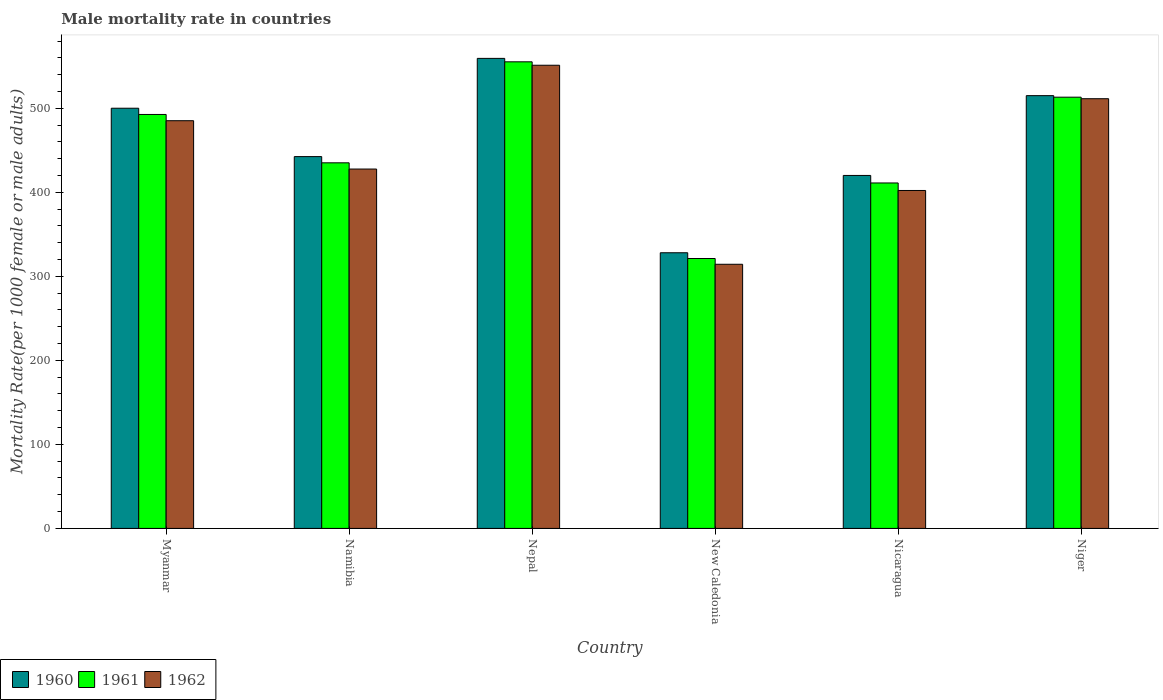How many different coloured bars are there?
Give a very brief answer. 3. Are the number of bars per tick equal to the number of legend labels?
Keep it short and to the point. Yes. How many bars are there on the 4th tick from the right?
Your answer should be very brief. 3. What is the label of the 2nd group of bars from the left?
Give a very brief answer. Namibia. In how many cases, is the number of bars for a given country not equal to the number of legend labels?
Your response must be concise. 0. What is the male mortality rate in 1962 in Nicaragua?
Your answer should be compact. 402.13. Across all countries, what is the maximum male mortality rate in 1962?
Make the answer very short. 551.15. Across all countries, what is the minimum male mortality rate in 1962?
Your answer should be very brief. 314.32. In which country was the male mortality rate in 1961 maximum?
Provide a succinct answer. Nepal. In which country was the male mortality rate in 1962 minimum?
Your response must be concise. New Caledonia. What is the total male mortality rate in 1960 in the graph?
Provide a succinct answer. 2764.8. What is the difference between the male mortality rate in 1961 in Namibia and that in Niger?
Give a very brief answer. -78.11. What is the difference between the male mortality rate in 1962 in Nepal and the male mortality rate in 1961 in New Caledonia?
Your answer should be very brief. 229.98. What is the average male mortality rate in 1960 per country?
Give a very brief answer. 460.8. What is the difference between the male mortality rate of/in 1960 and male mortality rate of/in 1962 in Niger?
Your answer should be compact. 3.64. In how many countries, is the male mortality rate in 1962 greater than 60?
Keep it short and to the point. 6. What is the ratio of the male mortality rate in 1961 in Myanmar to that in Niger?
Keep it short and to the point. 0.96. Is the male mortality rate in 1961 in Nicaragua less than that in Niger?
Give a very brief answer. Yes. What is the difference between the highest and the second highest male mortality rate in 1960?
Your answer should be very brief. 14.97. What is the difference between the highest and the lowest male mortality rate in 1961?
Your answer should be very brief. 234.07. What is the difference between two consecutive major ticks on the Y-axis?
Your answer should be compact. 100. Are the values on the major ticks of Y-axis written in scientific E-notation?
Provide a short and direct response. No. Does the graph contain any zero values?
Offer a terse response. No. Does the graph contain grids?
Your answer should be compact. No. What is the title of the graph?
Ensure brevity in your answer.  Male mortality rate in countries. What is the label or title of the Y-axis?
Provide a succinct answer. Mortality Rate(per 1000 female or male adults). What is the Mortality Rate(per 1000 female or male adults) in 1960 in Myanmar?
Provide a short and direct response. 500. What is the Mortality Rate(per 1000 female or male adults) of 1961 in Myanmar?
Provide a succinct answer. 492.58. What is the Mortality Rate(per 1000 female or male adults) of 1962 in Myanmar?
Keep it short and to the point. 485.16. What is the Mortality Rate(per 1000 female or male adults) of 1960 in Namibia?
Your answer should be compact. 442.45. What is the Mortality Rate(per 1000 female or male adults) of 1961 in Namibia?
Your answer should be compact. 435.05. What is the Mortality Rate(per 1000 female or male adults) in 1962 in Namibia?
Your response must be concise. 427.65. What is the Mortality Rate(per 1000 female or male adults) in 1960 in Nepal?
Keep it short and to the point. 559.33. What is the Mortality Rate(per 1000 female or male adults) of 1961 in Nepal?
Your response must be concise. 555.24. What is the Mortality Rate(per 1000 female or male adults) of 1962 in Nepal?
Offer a terse response. 551.15. What is the Mortality Rate(per 1000 female or male adults) in 1960 in New Caledonia?
Ensure brevity in your answer.  328.03. What is the Mortality Rate(per 1000 female or male adults) in 1961 in New Caledonia?
Provide a succinct answer. 321.17. What is the Mortality Rate(per 1000 female or male adults) in 1962 in New Caledonia?
Your answer should be very brief. 314.32. What is the Mortality Rate(per 1000 female or male adults) of 1960 in Nicaragua?
Provide a succinct answer. 420.02. What is the Mortality Rate(per 1000 female or male adults) in 1961 in Nicaragua?
Make the answer very short. 411.07. What is the Mortality Rate(per 1000 female or male adults) in 1962 in Nicaragua?
Keep it short and to the point. 402.13. What is the Mortality Rate(per 1000 female or male adults) of 1960 in Niger?
Ensure brevity in your answer.  514.98. What is the Mortality Rate(per 1000 female or male adults) of 1961 in Niger?
Give a very brief answer. 513.16. What is the Mortality Rate(per 1000 female or male adults) in 1962 in Niger?
Your answer should be compact. 511.34. Across all countries, what is the maximum Mortality Rate(per 1000 female or male adults) of 1960?
Provide a succinct answer. 559.33. Across all countries, what is the maximum Mortality Rate(per 1000 female or male adults) of 1961?
Your answer should be compact. 555.24. Across all countries, what is the maximum Mortality Rate(per 1000 female or male adults) of 1962?
Keep it short and to the point. 551.15. Across all countries, what is the minimum Mortality Rate(per 1000 female or male adults) in 1960?
Make the answer very short. 328.03. Across all countries, what is the minimum Mortality Rate(per 1000 female or male adults) of 1961?
Your answer should be very brief. 321.17. Across all countries, what is the minimum Mortality Rate(per 1000 female or male adults) of 1962?
Your answer should be compact. 314.32. What is the total Mortality Rate(per 1000 female or male adults) in 1960 in the graph?
Your response must be concise. 2764.8. What is the total Mortality Rate(per 1000 female or male adults) of 1961 in the graph?
Your answer should be very brief. 2728.27. What is the total Mortality Rate(per 1000 female or male adults) in 1962 in the graph?
Your answer should be very brief. 2691.74. What is the difference between the Mortality Rate(per 1000 female or male adults) in 1960 in Myanmar and that in Namibia?
Your answer should be compact. 57.56. What is the difference between the Mortality Rate(per 1000 female or male adults) of 1961 in Myanmar and that in Namibia?
Make the answer very short. 57.53. What is the difference between the Mortality Rate(per 1000 female or male adults) in 1962 in Myanmar and that in Namibia?
Your answer should be very brief. 57.51. What is the difference between the Mortality Rate(per 1000 female or male adults) in 1960 in Myanmar and that in Nepal?
Offer a very short reply. -59.32. What is the difference between the Mortality Rate(per 1000 female or male adults) in 1961 in Myanmar and that in Nepal?
Give a very brief answer. -62.66. What is the difference between the Mortality Rate(per 1000 female or male adults) in 1962 in Myanmar and that in Nepal?
Your answer should be very brief. -65.99. What is the difference between the Mortality Rate(per 1000 female or male adults) of 1960 in Myanmar and that in New Caledonia?
Your answer should be compact. 171.98. What is the difference between the Mortality Rate(per 1000 female or male adults) in 1961 in Myanmar and that in New Caledonia?
Your answer should be very brief. 171.41. What is the difference between the Mortality Rate(per 1000 female or male adults) in 1962 in Myanmar and that in New Caledonia?
Keep it short and to the point. 170.84. What is the difference between the Mortality Rate(per 1000 female or male adults) in 1960 in Myanmar and that in Nicaragua?
Your answer should be very brief. 79.99. What is the difference between the Mortality Rate(per 1000 female or male adults) in 1961 in Myanmar and that in Nicaragua?
Your answer should be compact. 81.51. What is the difference between the Mortality Rate(per 1000 female or male adults) of 1962 in Myanmar and that in Nicaragua?
Offer a terse response. 83.03. What is the difference between the Mortality Rate(per 1000 female or male adults) of 1960 in Myanmar and that in Niger?
Give a very brief answer. -14.97. What is the difference between the Mortality Rate(per 1000 female or male adults) in 1961 in Myanmar and that in Niger?
Provide a succinct answer. -20.57. What is the difference between the Mortality Rate(per 1000 female or male adults) of 1962 in Myanmar and that in Niger?
Provide a short and direct response. -26.18. What is the difference between the Mortality Rate(per 1000 female or male adults) in 1960 in Namibia and that in Nepal?
Your answer should be compact. -116.88. What is the difference between the Mortality Rate(per 1000 female or male adults) of 1961 in Namibia and that in Nepal?
Your answer should be very brief. -120.19. What is the difference between the Mortality Rate(per 1000 female or male adults) of 1962 in Namibia and that in Nepal?
Your answer should be very brief. -123.5. What is the difference between the Mortality Rate(per 1000 female or male adults) in 1960 in Namibia and that in New Caledonia?
Provide a short and direct response. 114.42. What is the difference between the Mortality Rate(per 1000 female or male adults) of 1961 in Namibia and that in New Caledonia?
Offer a terse response. 113.87. What is the difference between the Mortality Rate(per 1000 female or male adults) in 1962 in Namibia and that in New Caledonia?
Your answer should be compact. 113.33. What is the difference between the Mortality Rate(per 1000 female or male adults) of 1960 in Namibia and that in Nicaragua?
Keep it short and to the point. 22.43. What is the difference between the Mortality Rate(per 1000 female or male adults) in 1961 in Namibia and that in Nicaragua?
Keep it short and to the point. 23.98. What is the difference between the Mortality Rate(per 1000 female or male adults) in 1962 in Namibia and that in Nicaragua?
Provide a short and direct response. 25.52. What is the difference between the Mortality Rate(per 1000 female or male adults) in 1960 in Namibia and that in Niger?
Offer a terse response. -72.53. What is the difference between the Mortality Rate(per 1000 female or male adults) in 1961 in Namibia and that in Niger?
Your answer should be compact. -78.11. What is the difference between the Mortality Rate(per 1000 female or male adults) in 1962 in Namibia and that in Niger?
Offer a very short reply. -83.69. What is the difference between the Mortality Rate(per 1000 female or male adults) of 1960 in Nepal and that in New Caledonia?
Provide a succinct answer. 231.3. What is the difference between the Mortality Rate(per 1000 female or male adults) of 1961 in Nepal and that in New Caledonia?
Provide a short and direct response. 234.07. What is the difference between the Mortality Rate(per 1000 female or male adults) of 1962 in Nepal and that in New Caledonia?
Give a very brief answer. 236.83. What is the difference between the Mortality Rate(per 1000 female or male adults) in 1960 in Nepal and that in Nicaragua?
Your answer should be very brief. 139.31. What is the difference between the Mortality Rate(per 1000 female or male adults) of 1961 in Nepal and that in Nicaragua?
Provide a succinct answer. 144.17. What is the difference between the Mortality Rate(per 1000 female or male adults) in 1962 in Nepal and that in Nicaragua?
Offer a terse response. 149.02. What is the difference between the Mortality Rate(per 1000 female or male adults) in 1960 in Nepal and that in Niger?
Your answer should be very brief. 44.35. What is the difference between the Mortality Rate(per 1000 female or male adults) in 1961 in Nepal and that in Niger?
Your answer should be compact. 42.08. What is the difference between the Mortality Rate(per 1000 female or male adults) of 1962 in Nepal and that in Niger?
Your response must be concise. 39.81. What is the difference between the Mortality Rate(per 1000 female or male adults) in 1960 in New Caledonia and that in Nicaragua?
Your response must be concise. -91.99. What is the difference between the Mortality Rate(per 1000 female or male adults) in 1961 in New Caledonia and that in Nicaragua?
Your response must be concise. -89.9. What is the difference between the Mortality Rate(per 1000 female or male adults) of 1962 in New Caledonia and that in Nicaragua?
Your answer should be compact. -87.81. What is the difference between the Mortality Rate(per 1000 female or male adults) of 1960 in New Caledonia and that in Niger?
Offer a terse response. -186.95. What is the difference between the Mortality Rate(per 1000 female or male adults) in 1961 in New Caledonia and that in Niger?
Your answer should be compact. -191.98. What is the difference between the Mortality Rate(per 1000 female or male adults) in 1962 in New Caledonia and that in Niger?
Your response must be concise. -197.02. What is the difference between the Mortality Rate(per 1000 female or male adults) of 1960 in Nicaragua and that in Niger?
Offer a very short reply. -94.96. What is the difference between the Mortality Rate(per 1000 female or male adults) in 1961 in Nicaragua and that in Niger?
Your response must be concise. -102.08. What is the difference between the Mortality Rate(per 1000 female or male adults) of 1962 in Nicaragua and that in Niger?
Make the answer very short. -109.21. What is the difference between the Mortality Rate(per 1000 female or male adults) of 1960 in Myanmar and the Mortality Rate(per 1000 female or male adults) of 1961 in Namibia?
Your answer should be compact. 64.96. What is the difference between the Mortality Rate(per 1000 female or male adults) of 1960 in Myanmar and the Mortality Rate(per 1000 female or male adults) of 1962 in Namibia?
Your answer should be very brief. 72.36. What is the difference between the Mortality Rate(per 1000 female or male adults) in 1961 in Myanmar and the Mortality Rate(per 1000 female or male adults) in 1962 in Namibia?
Give a very brief answer. 64.94. What is the difference between the Mortality Rate(per 1000 female or male adults) in 1960 in Myanmar and the Mortality Rate(per 1000 female or male adults) in 1961 in Nepal?
Your answer should be very brief. -55.23. What is the difference between the Mortality Rate(per 1000 female or male adults) in 1960 in Myanmar and the Mortality Rate(per 1000 female or male adults) in 1962 in Nepal?
Your response must be concise. -51.15. What is the difference between the Mortality Rate(per 1000 female or male adults) of 1961 in Myanmar and the Mortality Rate(per 1000 female or male adults) of 1962 in Nepal?
Provide a succinct answer. -58.57. What is the difference between the Mortality Rate(per 1000 female or male adults) of 1960 in Myanmar and the Mortality Rate(per 1000 female or male adults) of 1961 in New Caledonia?
Ensure brevity in your answer.  178.83. What is the difference between the Mortality Rate(per 1000 female or male adults) of 1960 in Myanmar and the Mortality Rate(per 1000 female or male adults) of 1962 in New Caledonia?
Your answer should be very brief. 185.69. What is the difference between the Mortality Rate(per 1000 female or male adults) in 1961 in Myanmar and the Mortality Rate(per 1000 female or male adults) in 1962 in New Caledonia?
Make the answer very short. 178.26. What is the difference between the Mortality Rate(per 1000 female or male adults) in 1960 in Myanmar and the Mortality Rate(per 1000 female or male adults) in 1961 in Nicaragua?
Give a very brief answer. 88.93. What is the difference between the Mortality Rate(per 1000 female or male adults) of 1960 in Myanmar and the Mortality Rate(per 1000 female or male adults) of 1962 in Nicaragua?
Offer a very short reply. 97.88. What is the difference between the Mortality Rate(per 1000 female or male adults) in 1961 in Myanmar and the Mortality Rate(per 1000 female or male adults) in 1962 in Nicaragua?
Offer a very short reply. 90.45. What is the difference between the Mortality Rate(per 1000 female or male adults) of 1960 in Myanmar and the Mortality Rate(per 1000 female or male adults) of 1961 in Niger?
Your answer should be very brief. -13.15. What is the difference between the Mortality Rate(per 1000 female or male adults) in 1960 in Myanmar and the Mortality Rate(per 1000 female or male adults) in 1962 in Niger?
Give a very brief answer. -11.33. What is the difference between the Mortality Rate(per 1000 female or male adults) in 1961 in Myanmar and the Mortality Rate(per 1000 female or male adults) in 1962 in Niger?
Offer a very short reply. -18.75. What is the difference between the Mortality Rate(per 1000 female or male adults) in 1960 in Namibia and the Mortality Rate(per 1000 female or male adults) in 1961 in Nepal?
Offer a terse response. -112.79. What is the difference between the Mortality Rate(per 1000 female or male adults) of 1960 in Namibia and the Mortality Rate(per 1000 female or male adults) of 1962 in Nepal?
Keep it short and to the point. -108.7. What is the difference between the Mortality Rate(per 1000 female or male adults) in 1961 in Namibia and the Mortality Rate(per 1000 female or male adults) in 1962 in Nepal?
Keep it short and to the point. -116.1. What is the difference between the Mortality Rate(per 1000 female or male adults) of 1960 in Namibia and the Mortality Rate(per 1000 female or male adults) of 1961 in New Caledonia?
Offer a terse response. 121.27. What is the difference between the Mortality Rate(per 1000 female or male adults) in 1960 in Namibia and the Mortality Rate(per 1000 female or male adults) in 1962 in New Caledonia?
Give a very brief answer. 128.13. What is the difference between the Mortality Rate(per 1000 female or male adults) of 1961 in Namibia and the Mortality Rate(per 1000 female or male adults) of 1962 in New Caledonia?
Offer a very short reply. 120.73. What is the difference between the Mortality Rate(per 1000 female or male adults) in 1960 in Namibia and the Mortality Rate(per 1000 female or male adults) in 1961 in Nicaragua?
Make the answer very short. 31.38. What is the difference between the Mortality Rate(per 1000 female or male adults) in 1960 in Namibia and the Mortality Rate(per 1000 female or male adults) in 1962 in Nicaragua?
Give a very brief answer. 40.32. What is the difference between the Mortality Rate(per 1000 female or male adults) in 1961 in Namibia and the Mortality Rate(per 1000 female or male adults) in 1962 in Nicaragua?
Ensure brevity in your answer.  32.92. What is the difference between the Mortality Rate(per 1000 female or male adults) of 1960 in Namibia and the Mortality Rate(per 1000 female or male adults) of 1961 in Niger?
Keep it short and to the point. -70.71. What is the difference between the Mortality Rate(per 1000 female or male adults) of 1960 in Namibia and the Mortality Rate(per 1000 female or male adults) of 1962 in Niger?
Provide a succinct answer. -68.89. What is the difference between the Mortality Rate(per 1000 female or male adults) in 1961 in Namibia and the Mortality Rate(per 1000 female or male adults) in 1962 in Niger?
Give a very brief answer. -76.29. What is the difference between the Mortality Rate(per 1000 female or male adults) in 1960 in Nepal and the Mortality Rate(per 1000 female or male adults) in 1961 in New Caledonia?
Keep it short and to the point. 238.16. What is the difference between the Mortality Rate(per 1000 female or male adults) of 1960 in Nepal and the Mortality Rate(per 1000 female or male adults) of 1962 in New Caledonia?
Give a very brief answer. 245.01. What is the difference between the Mortality Rate(per 1000 female or male adults) of 1961 in Nepal and the Mortality Rate(per 1000 female or male adults) of 1962 in New Caledonia?
Your response must be concise. 240.92. What is the difference between the Mortality Rate(per 1000 female or male adults) of 1960 in Nepal and the Mortality Rate(per 1000 female or male adults) of 1961 in Nicaragua?
Keep it short and to the point. 148.26. What is the difference between the Mortality Rate(per 1000 female or male adults) of 1960 in Nepal and the Mortality Rate(per 1000 female or male adults) of 1962 in Nicaragua?
Your answer should be very brief. 157.2. What is the difference between the Mortality Rate(per 1000 female or male adults) of 1961 in Nepal and the Mortality Rate(per 1000 female or male adults) of 1962 in Nicaragua?
Ensure brevity in your answer.  153.11. What is the difference between the Mortality Rate(per 1000 female or male adults) of 1960 in Nepal and the Mortality Rate(per 1000 female or male adults) of 1961 in Niger?
Provide a succinct answer. 46.17. What is the difference between the Mortality Rate(per 1000 female or male adults) of 1960 in Nepal and the Mortality Rate(per 1000 female or male adults) of 1962 in Niger?
Your response must be concise. 47.99. What is the difference between the Mortality Rate(per 1000 female or male adults) in 1961 in Nepal and the Mortality Rate(per 1000 female or male adults) in 1962 in Niger?
Provide a short and direct response. 43.9. What is the difference between the Mortality Rate(per 1000 female or male adults) in 1960 in New Caledonia and the Mortality Rate(per 1000 female or male adults) in 1961 in Nicaragua?
Offer a very short reply. -83.05. What is the difference between the Mortality Rate(per 1000 female or male adults) in 1960 in New Caledonia and the Mortality Rate(per 1000 female or male adults) in 1962 in Nicaragua?
Make the answer very short. -74.1. What is the difference between the Mortality Rate(per 1000 female or male adults) of 1961 in New Caledonia and the Mortality Rate(per 1000 female or male adults) of 1962 in Nicaragua?
Your answer should be very brief. -80.96. What is the difference between the Mortality Rate(per 1000 female or male adults) of 1960 in New Caledonia and the Mortality Rate(per 1000 female or male adults) of 1961 in Niger?
Ensure brevity in your answer.  -185.13. What is the difference between the Mortality Rate(per 1000 female or male adults) of 1960 in New Caledonia and the Mortality Rate(per 1000 female or male adults) of 1962 in Niger?
Your response must be concise. -183.31. What is the difference between the Mortality Rate(per 1000 female or male adults) of 1961 in New Caledonia and the Mortality Rate(per 1000 female or male adults) of 1962 in Niger?
Your answer should be very brief. -190.16. What is the difference between the Mortality Rate(per 1000 female or male adults) in 1960 in Nicaragua and the Mortality Rate(per 1000 female or male adults) in 1961 in Niger?
Offer a very short reply. -93.14. What is the difference between the Mortality Rate(per 1000 female or male adults) of 1960 in Nicaragua and the Mortality Rate(per 1000 female or male adults) of 1962 in Niger?
Your answer should be compact. -91.32. What is the difference between the Mortality Rate(per 1000 female or male adults) of 1961 in Nicaragua and the Mortality Rate(per 1000 female or male adults) of 1962 in Niger?
Offer a terse response. -100.26. What is the average Mortality Rate(per 1000 female or male adults) in 1960 per country?
Your answer should be compact. 460.8. What is the average Mortality Rate(per 1000 female or male adults) of 1961 per country?
Make the answer very short. 454.71. What is the average Mortality Rate(per 1000 female or male adults) of 1962 per country?
Your response must be concise. 448.62. What is the difference between the Mortality Rate(per 1000 female or male adults) in 1960 and Mortality Rate(per 1000 female or male adults) in 1961 in Myanmar?
Offer a very short reply. 7.42. What is the difference between the Mortality Rate(per 1000 female or male adults) of 1960 and Mortality Rate(per 1000 female or male adults) of 1962 in Myanmar?
Give a very brief answer. 14.85. What is the difference between the Mortality Rate(per 1000 female or male adults) of 1961 and Mortality Rate(per 1000 female or male adults) of 1962 in Myanmar?
Offer a very short reply. 7.42. What is the difference between the Mortality Rate(per 1000 female or male adults) in 1960 and Mortality Rate(per 1000 female or male adults) in 1962 in Namibia?
Provide a short and direct response. 14.8. What is the difference between the Mortality Rate(per 1000 female or male adults) in 1961 and Mortality Rate(per 1000 female or male adults) in 1962 in Namibia?
Your answer should be very brief. 7.4. What is the difference between the Mortality Rate(per 1000 female or male adults) in 1960 and Mortality Rate(per 1000 female or male adults) in 1961 in Nepal?
Ensure brevity in your answer.  4.09. What is the difference between the Mortality Rate(per 1000 female or male adults) of 1960 and Mortality Rate(per 1000 female or male adults) of 1962 in Nepal?
Keep it short and to the point. 8.18. What is the difference between the Mortality Rate(per 1000 female or male adults) of 1961 and Mortality Rate(per 1000 female or male adults) of 1962 in Nepal?
Your answer should be compact. 4.09. What is the difference between the Mortality Rate(per 1000 female or male adults) of 1960 and Mortality Rate(per 1000 female or male adults) of 1961 in New Caledonia?
Your response must be concise. 6.85. What is the difference between the Mortality Rate(per 1000 female or male adults) of 1960 and Mortality Rate(per 1000 female or male adults) of 1962 in New Caledonia?
Provide a succinct answer. 13.71. What is the difference between the Mortality Rate(per 1000 female or male adults) of 1961 and Mortality Rate(per 1000 female or male adults) of 1962 in New Caledonia?
Ensure brevity in your answer.  6.85. What is the difference between the Mortality Rate(per 1000 female or male adults) in 1960 and Mortality Rate(per 1000 female or male adults) in 1961 in Nicaragua?
Provide a succinct answer. 8.94. What is the difference between the Mortality Rate(per 1000 female or male adults) in 1960 and Mortality Rate(per 1000 female or male adults) in 1962 in Nicaragua?
Your answer should be very brief. 17.89. What is the difference between the Mortality Rate(per 1000 female or male adults) in 1961 and Mortality Rate(per 1000 female or male adults) in 1962 in Nicaragua?
Your response must be concise. 8.94. What is the difference between the Mortality Rate(per 1000 female or male adults) in 1960 and Mortality Rate(per 1000 female or male adults) in 1961 in Niger?
Offer a very short reply. 1.82. What is the difference between the Mortality Rate(per 1000 female or male adults) of 1960 and Mortality Rate(per 1000 female or male adults) of 1962 in Niger?
Keep it short and to the point. 3.64. What is the difference between the Mortality Rate(per 1000 female or male adults) in 1961 and Mortality Rate(per 1000 female or male adults) in 1962 in Niger?
Provide a short and direct response. 1.82. What is the ratio of the Mortality Rate(per 1000 female or male adults) of 1960 in Myanmar to that in Namibia?
Your answer should be very brief. 1.13. What is the ratio of the Mortality Rate(per 1000 female or male adults) in 1961 in Myanmar to that in Namibia?
Provide a succinct answer. 1.13. What is the ratio of the Mortality Rate(per 1000 female or male adults) of 1962 in Myanmar to that in Namibia?
Offer a very short reply. 1.13. What is the ratio of the Mortality Rate(per 1000 female or male adults) in 1960 in Myanmar to that in Nepal?
Offer a terse response. 0.89. What is the ratio of the Mortality Rate(per 1000 female or male adults) in 1961 in Myanmar to that in Nepal?
Ensure brevity in your answer.  0.89. What is the ratio of the Mortality Rate(per 1000 female or male adults) of 1962 in Myanmar to that in Nepal?
Your answer should be compact. 0.88. What is the ratio of the Mortality Rate(per 1000 female or male adults) in 1960 in Myanmar to that in New Caledonia?
Give a very brief answer. 1.52. What is the ratio of the Mortality Rate(per 1000 female or male adults) in 1961 in Myanmar to that in New Caledonia?
Your answer should be compact. 1.53. What is the ratio of the Mortality Rate(per 1000 female or male adults) of 1962 in Myanmar to that in New Caledonia?
Make the answer very short. 1.54. What is the ratio of the Mortality Rate(per 1000 female or male adults) in 1960 in Myanmar to that in Nicaragua?
Make the answer very short. 1.19. What is the ratio of the Mortality Rate(per 1000 female or male adults) of 1961 in Myanmar to that in Nicaragua?
Give a very brief answer. 1.2. What is the ratio of the Mortality Rate(per 1000 female or male adults) in 1962 in Myanmar to that in Nicaragua?
Make the answer very short. 1.21. What is the ratio of the Mortality Rate(per 1000 female or male adults) of 1960 in Myanmar to that in Niger?
Your answer should be compact. 0.97. What is the ratio of the Mortality Rate(per 1000 female or male adults) of 1961 in Myanmar to that in Niger?
Your answer should be very brief. 0.96. What is the ratio of the Mortality Rate(per 1000 female or male adults) of 1962 in Myanmar to that in Niger?
Ensure brevity in your answer.  0.95. What is the ratio of the Mortality Rate(per 1000 female or male adults) of 1960 in Namibia to that in Nepal?
Provide a succinct answer. 0.79. What is the ratio of the Mortality Rate(per 1000 female or male adults) of 1961 in Namibia to that in Nepal?
Make the answer very short. 0.78. What is the ratio of the Mortality Rate(per 1000 female or male adults) of 1962 in Namibia to that in Nepal?
Your answer should be compact. 0.78. What is the ratio of the Mortality Rate(per 1000 female or male adults) in 1960 in Namibia to that in New Caledonia?
Ensure brevity in your answer.  1.35. What is the ratio of the Mortality Rate(per 1000 female or male adults) in 1961 in Namibia to that in New Caledonia?
Ensure brevity in your answer.  1.35. What is the ratio of the Mortality Rate(per 1000 female or male adults) in 1962 in Namibia to that in New Caledonia?
Offer a terse response. 1.36. What is the ratio of the Mortality Rate(per 1000 female or male adults) of 1960 in Namibia to that in Nicaragua?
Your answer should be very brief. 1.05. What is the ratio of the Mortality Rate(per 1000 female or male adults) in 1961 in Namibia to that in Nicaragua?
Your answer should be very brief. 1.06. What is the ratio of the Mortality Rate(per 1000 female or male adults) of 1962 in Namibia to that in Nicaragua?
Offer a very short reply. 1.06. What is the ratio of the Mortality Rate(per 1000 female or male adults) in 1960 in Namibia to that in Niger?
Your answer should be compact. 0.86. What is the ratio of the Mortality Rate(per 1000 female or male adults) of 1961 in Namibia to that in Niger?
Keep it short and to the point. 0.85. What is the ratio of the Mortality Rate(per 1000 female or male adults) of 1962 in Namibia to that in Niger?
Ensure brevity in your answer.  0.84. What is the ratio of the Mortality Rate(per 1000 female or male adults) of 1960 in Nepal to that in New Caledonia?
Offer a very short reply. 1.71. What is the ratio of the Mortality Rate(per 1000 female or male adults) in 1961 in Nepal to that in New Caledonia?
Your response must be concise. 1.73. What is the ratio of the Mortality Rate(per 1000 female or male adults) of 1962 in Nepal to that in New Caledonia?
Make the answer very short. 1.75. What is the ratio of the Mortality Rate(per 1000 female or male adults) of 1960 in Nepal to that in Nicaragua?
Keep it short and to the point. 1.33. What is the ratio of the Mortality Rate(per 1000 female or male adults) of 1961 in Nepal to that in Nicaragua?
Offer a very short reply. 1.35. What is the ratio of the Mortality Rate(per 1000 female or male adults) in 1962 in Nepal to that in Nicaragua?
Make the answer very short. 1.37. What is the ratio of the Mortality Rate(per 1000 female or male adults) of 1960 in Nepal to that in Niger?
Your answer should be very brief. 1.09. What is the ratio of the Mortality Rate(per 1000 female or male adults) of 1961 in Nepal to that in Niger?
Your answer should be compact. 1.08. What is the ratio of the Mortality Rate(per 1000 female or male adults) of 1962 in Nepal to that in Niger?
Provide a short and direct response. 1.08. What is the ratio of the Mortality Rate(per 1000 female or male adults) in 1960 in New Caledonia to that in Nicaragua?
Ensure brevity in your answer.  0.78. What is the ratio of the Mortality Rate(per 1000 female or male adults) in 1961 in New Caledonia to that in Nicaragua?
Your response must be concise. 0.78. What is the ratio of the Mortality Rate(per 1000 female or male adults) of 1962 in New Caledonia to that in Nicaragua?
Your response must be concise. 0.78. What is the ratio of the Mortality Rate(per 1000 female or male adults) of 1960 in New Caledonia to that in Niger?
Ensure brevity in your answer.  0.64. What is the ratio of the Mortality Rate(per 1000 female or male adults) of 1961 in New Caledonia to that in Niger?
Offer a very short reply. 0.63. What is the ratio of the Mortality Rate(per 1000 female or male adults) in 1962 in New Caledonia to that in Niger?
Your response must be concise. 0.61. What is the ratio of the Mortality Rate(per 1000 female or male adults) of 1960 in Nicaragua to that in Niger?
Keep it short and to the point. 0.82. What is the ratio of the Mortality Rate(per 1000 female or male adults) in 1961 in Nicaragua to that in Niger?
Make the answer very short. 0.8. What is the ratio of the Mortality Rate(per 1000 female or male adults) of 1962 in Nicaragua to that in Niger?
Ensure brevity in your answer.  0.79. What is the difference between the highest and the second highest Mortality Rate(per 1000 female or male adults) in 1960?
Offer a very short reply. 44.35. What is the difference between the highest and the second highest Mortality Rate(per 1000 female or male adults) in 1961?
Your response must be concise. 42.08. What is the difference between the highest and the second highest Mortality Rate(per 1000 female or male adults) of 1962?
Your response must be concise. 39.81. What is the difference between the highest and the lowest Mortality Rate(per 1000 female or male adults) in 1960?
Offer a terse response. 231.3. What is the difference between the highest and the lowest Mortality Rate(per 1000 female or male adults) of 1961?
Offer a very short reply. 234.07. What is the difference between the highest and the lowest Mortality Rate(per 1000 female or male adults) in 1962?
Offer a very short reply. 236.83. 